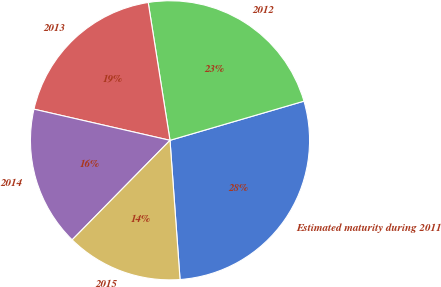Convert chart to OTSL. <chart><loc_0><loc_0><loc_500><loc_500><pie_chart><fcel>Estimated maturity during 2011<fcel>2012<fcel>2013<fcel>2014<fcel>2015<nl><fcel>28.38%<fcel>22.97%<fcel>18.92%<fcel>16.22%<fcel>13.51%<nl></chart> 